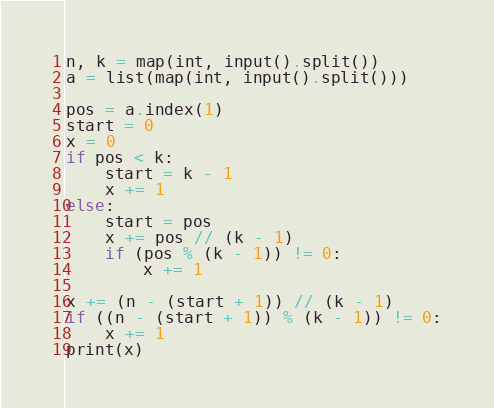<code> <loc_0><loc_0><loc_500><loc_500><_Python_>n, k = map(int, input().split())
a = list(map(int, input().split()))

pos = a.index(1)
start = 0
x = 0
if pos < k:
    start = k - 1
    x += 1
else:
    start = pos
    x += pos // (k - 1)
    if (pos % (k - 1)) != 0:
        x += 1

x += (n - (start + 1)) // (k - 1)
if ((n - (start + 1)) % (k - 1)) != 0:
    x += 1
print(x)</code> 